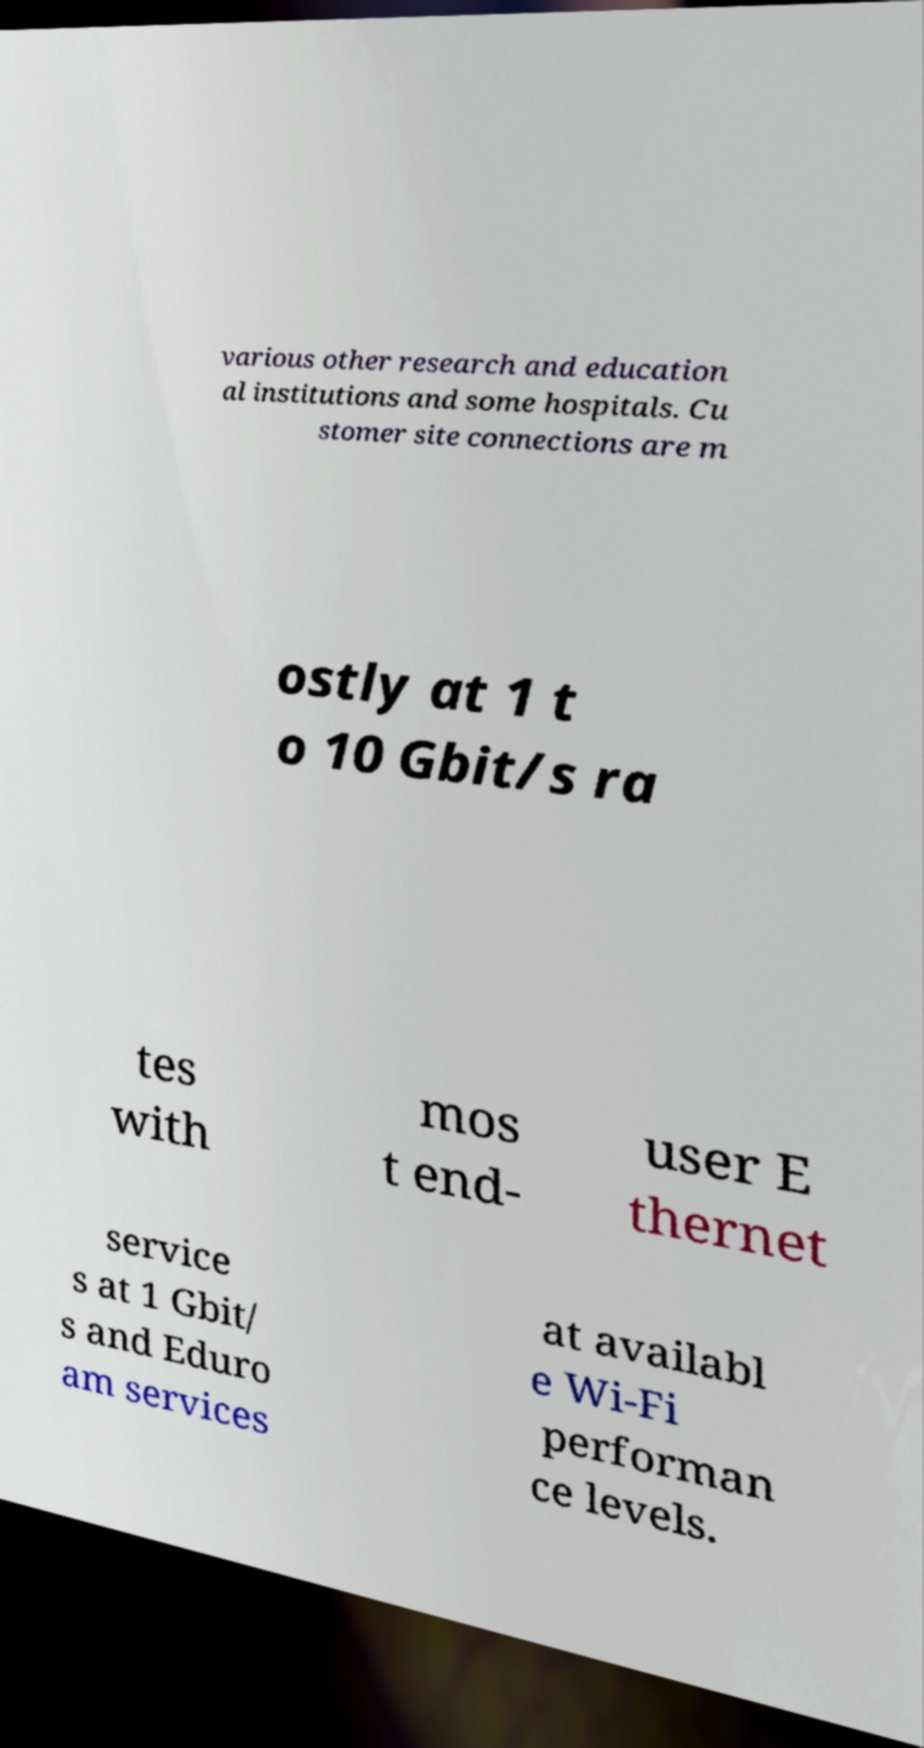I need the written content from this picture converted into text. Can you do that? various other research and education al institutions and some hospitals. Cu stomer site connections are m ostly at 1 t o 10 Gbit/s ra tes with mos t end- user E thernet service s at 1 Gbit/ s and Eduro am services at availabl e Wi-Fi performan ce levels. 